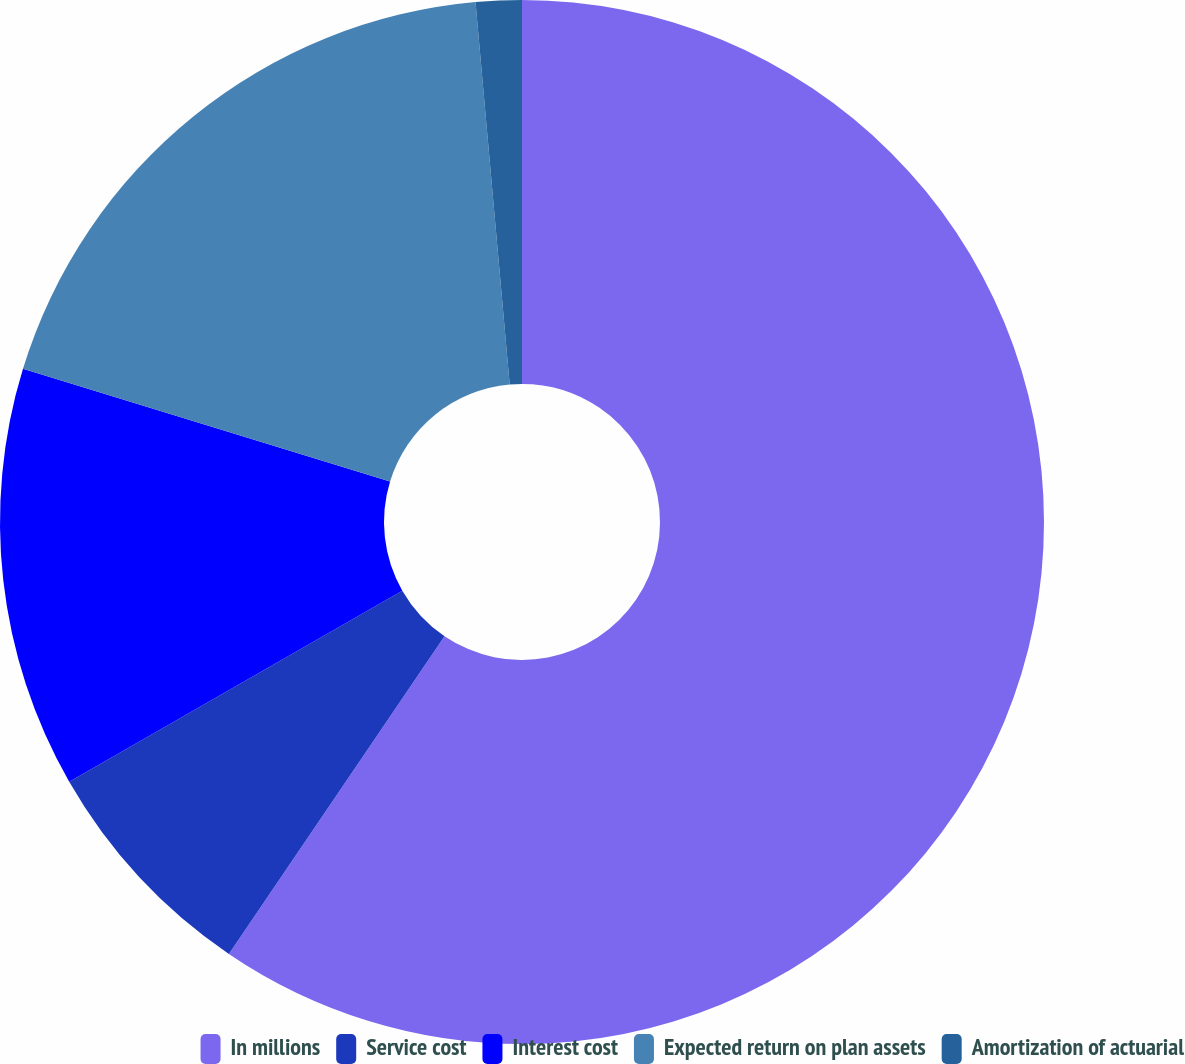<chart> <loc_0><loc_0><loc_500><loc_500><pie_chart><fcel>In millions<fcel>Service cost<fcel>Interest cost<fcel>Expected return on plan assets<fcel>Amortization of actuarial<nl><fcel>59.49%<fcel>7.22%<fcel>13.03%<fcel>18.84%<fcel>1.42%<nl></chart> 